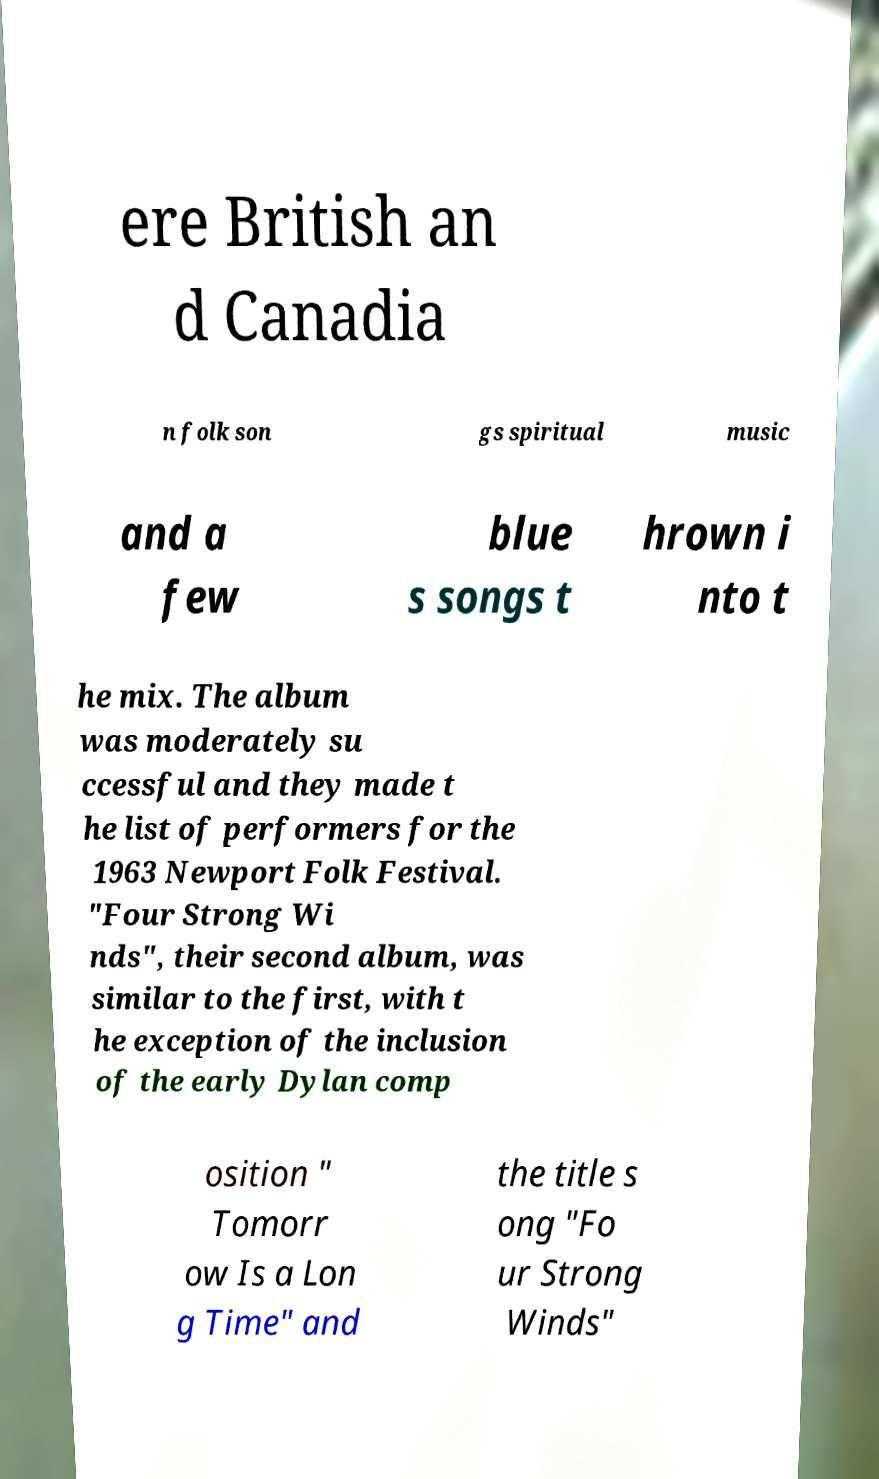Can you accurately transcribe the text from the provided image for me? ere British an d Canadia n folk son gs spiritual music and a few blue s songs t hrown i nto t he mix. The album was moderately su ccessful and they made t he list of performers for the 1963 Newport Folk Festival. "Four Strong Wi nds", their second album, was similar to the first, with t he exception of the inclusion of the early Dylan comp osition " Tomorr ow Is a Lon g Time" and the title s ong "Fo ur Strong Winds" 